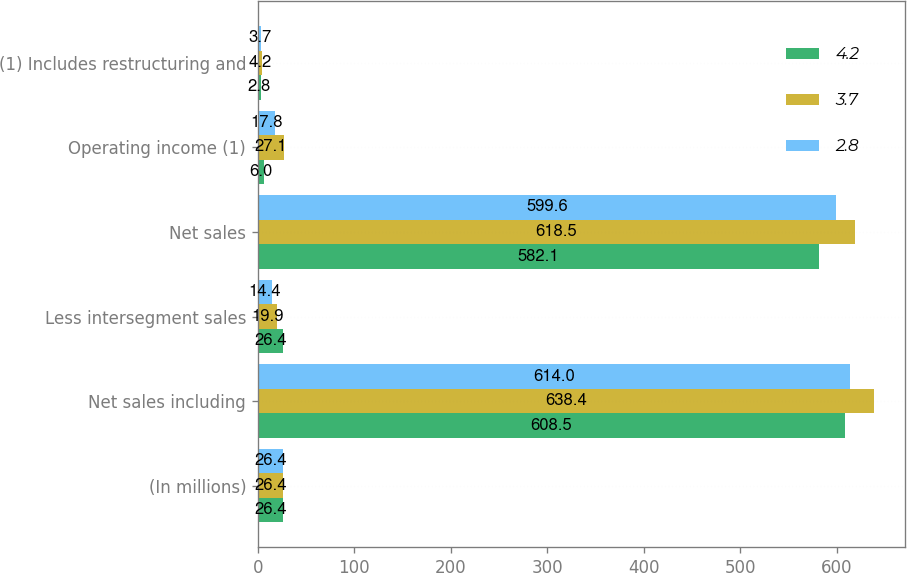<chart> <loc_0><loc_0><loc_500><loc_500><stacked_bar_chart><ecel><fcel>(In millions)<fcel>Net sales including<fcel>Less intersegment sales<fcel>Net sales<fcel>Operating income (1)<fcel>(1) Includes restructuring and<nl><fcel>4.2<fcel>26.4<fcel>608.5<fcel>26.4<fcel>582.1<fcel>6<fcel>2.8<nl><fcel>3.7<fcel>26.4<fcel>638.4<fcel>19.9<fcel>618.5<fcel>27.1<fcel>4.2<nl><fcel>2.8<fcel>26.4<fcel>614<fcel>14.4<fcel>599.6<fcel>17.8<fcel>3.7<nl></chart> 